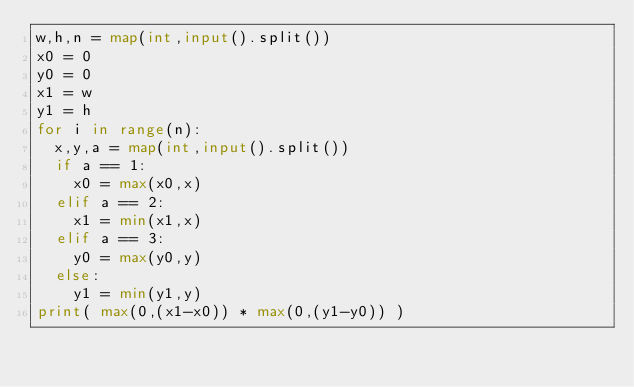Convert code to text. <code><loc_0><loc_0><loc_500><loc_500><_Python_>w,h,n = map(int,input().split())
x0 = 0
y0 = 0
x1 = w
y1 = h
for i in range(n):
  x,y,a = map(int,input().split())
  if a == 1:
    x0 = max(x0,x)
  elif a == 2:
    x1 = min(x1,x)
  elif a == 3:
    y0 = max(y0,y)
  else:
    y1 = min(y1,y)
print( max(0,(x1-x0)) * max(0,(y1-y0)) )</code> 